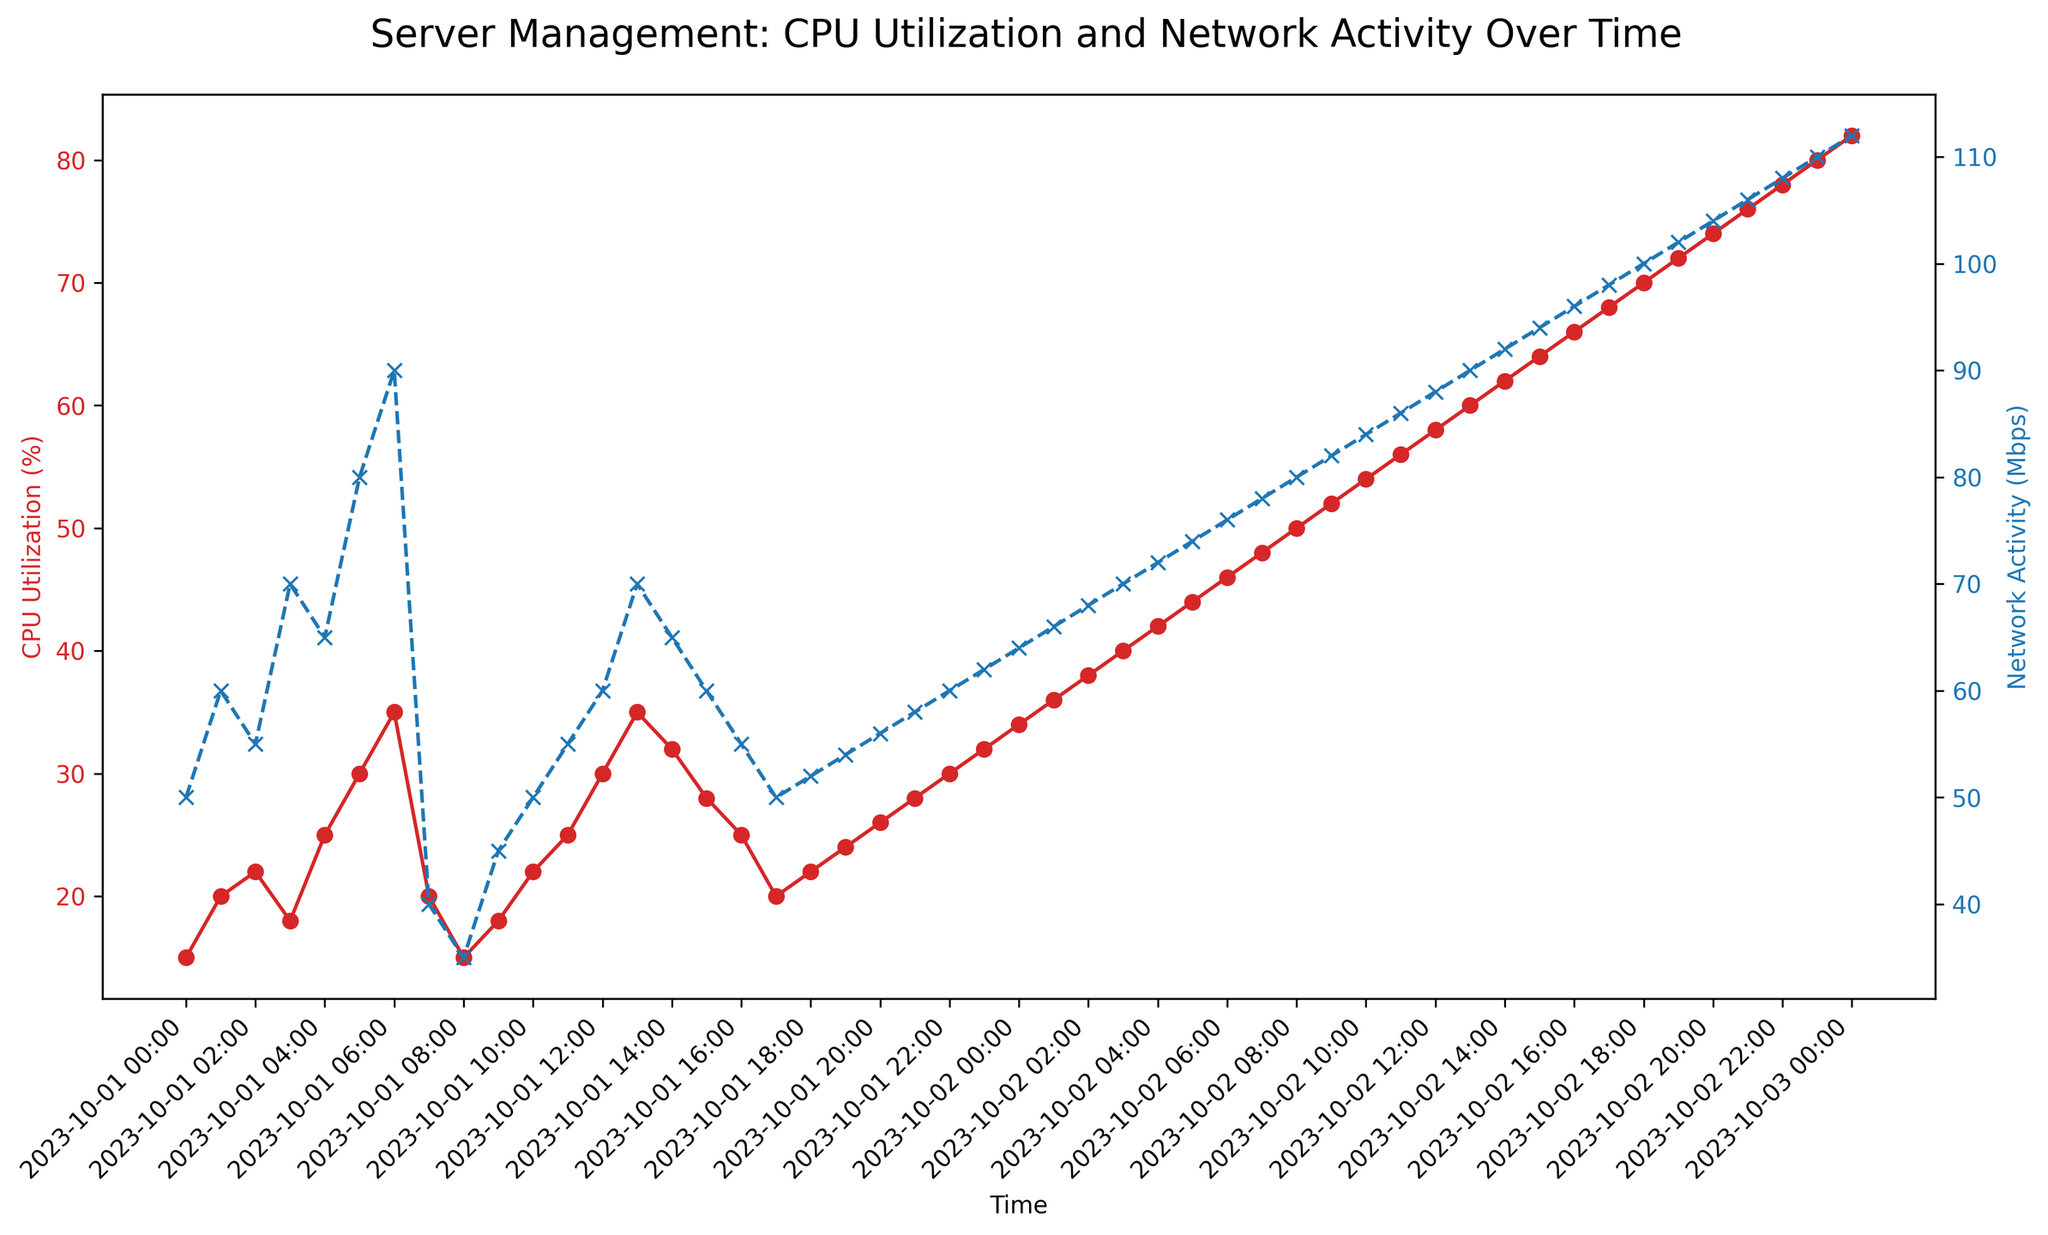What is the average CPU Utilization (%) over the entire period? To find the average CPU Utilization %, sum up all values and divide by the number of data points. The sum is (15+20+22...+80+82) = 2120, and there are 48 data points. Thus, the average is 2120/48.
Answer: 44.17 During which timeframe does Network Activity (Mbps) surpass 105 Mbps? Observe the secondary y-axis (Network Activity, blue line). Spot where it crosses 105 Mbps. Network Activity surpasses 105 Mbps from 2023-10-02 21:00 to 2023-10-02 23:00.
Answer: 2023-10-02 21:00 to 2023-10-02 23:00 What is the difference in CPU Utilization (%) between the first and last recorded timestamp? Look at the start (2023-10-01 00:00, 15%) and end (2023-10-03 00:00, 82%) of the red line. The difference is 82% - 15%.
Answer: 67% When does the CPU Utilization (%) first reach 50%? Check the primary y-axis (CPU Utilization, red line), marking when it first hits 50%. This occurs at 2023-10-02 08:00.
Answer: 2023-10-02 08:00 Is there a timeframe where both CPU Utilization (%) and Network Activity (Mbps) decrease? Look for periods where both the red and blue lines descend. From 2023-10-01 07:00 to 2023-10-01 08:00, CPU Utilization drops from 20% to 15%, and Network Activity from 40 Mbps to 35 Mbps.
Answer: 2023-10-01 07:00 to 2023-10-01 08:00 What is the maximum CPU Utilization (%) observed, and when does it occur? Find the highest point on the red line and note the corresponding time. The maximum CPU Utilization is 82%, occurring at 2023-10-03 00:00.
Answer: 82% at 2023-10-03 00:00 How many times does Network Activity (Mbps) reach exactly 70 Mbps? Check the blue line and note each time it touches 70 Mbps exactly. It reaches 70 Mbps twice (2023-10-01 03:00 and 2023-10-02 03:00).
Answer: 2 times Compare the CPU Utilization (%) and Network Activity (Mbps) at 2023-10-01 05:00 and 2023-10-02 05:00. Which value increased more? Calculate the differences for both metrics: CPU (44% - 30% = 14%) and Network Activity (74 Mbps - 80 Mbps = -6 Mbps). Check which increase is greater. CPU Utilization increased more by 14%.
Answer: CPU Utilization increased more by 14% When was the largest difference between CPU Utilization (%) and Network Activity (Mbps)? Examine both lines and identify where their difference is greatest. This happens at 2023-10-02 23:00 with a difference of 48 (110-62).
Answer: 2023-10-02 23:00 Between 2023-10-01 12:00 and 2023-10-02 12:00, what’s the average Network Activity (Mbps)? Sum Network Activity values between these times and divide by the number of data points. The sum is (60+70+65+...+88) = 1498, and there are 25 data points. Therefore, the average is 1498/25.
Answer: 59.92 